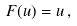<formula> <loc_0><loc_0><loc_500><loc_500>F ( u ) = u \, ,</formula> 